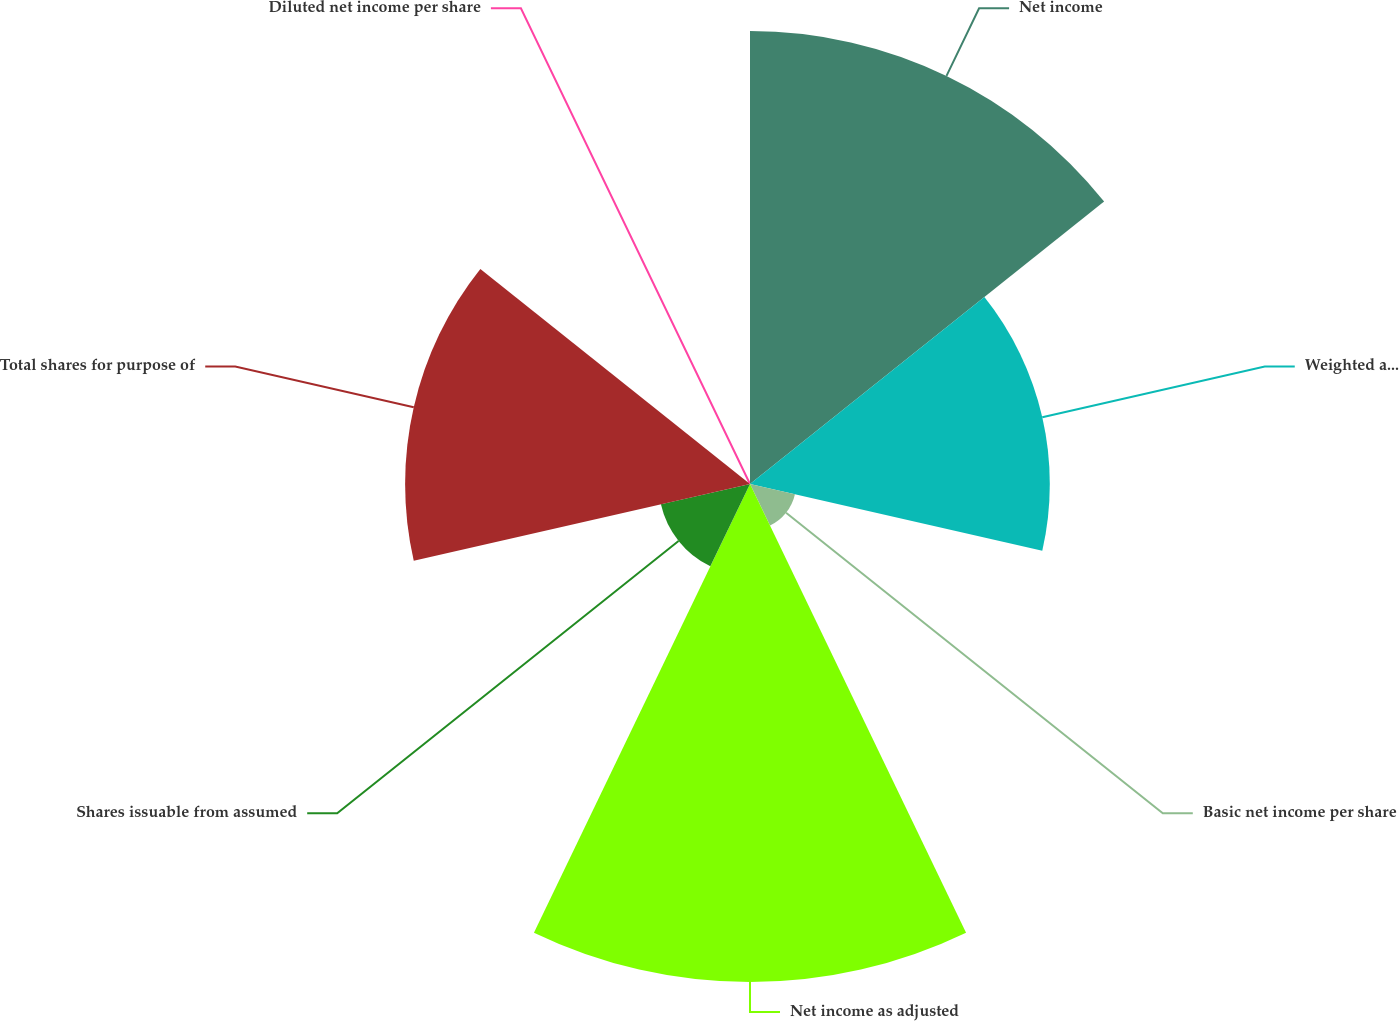Convert chart. <chart><loc_0><loc_0><loc_500><loc_500><pie_chart><fcel>Net income<fcel>Weighted average number of<fcel>Basic net income per share<fcel>Net income as adjusted<fcel>Shares issuable from assumed<fcel>Total shares for purpose of<fcel>Diluted net income per share<nl><fcel>26.12%<fcel>17.29%<fcel>2.66%<fcel>28.72%<fcel>5.27%<fcel>19.89%<fcel>0.05%<nl></chart> 